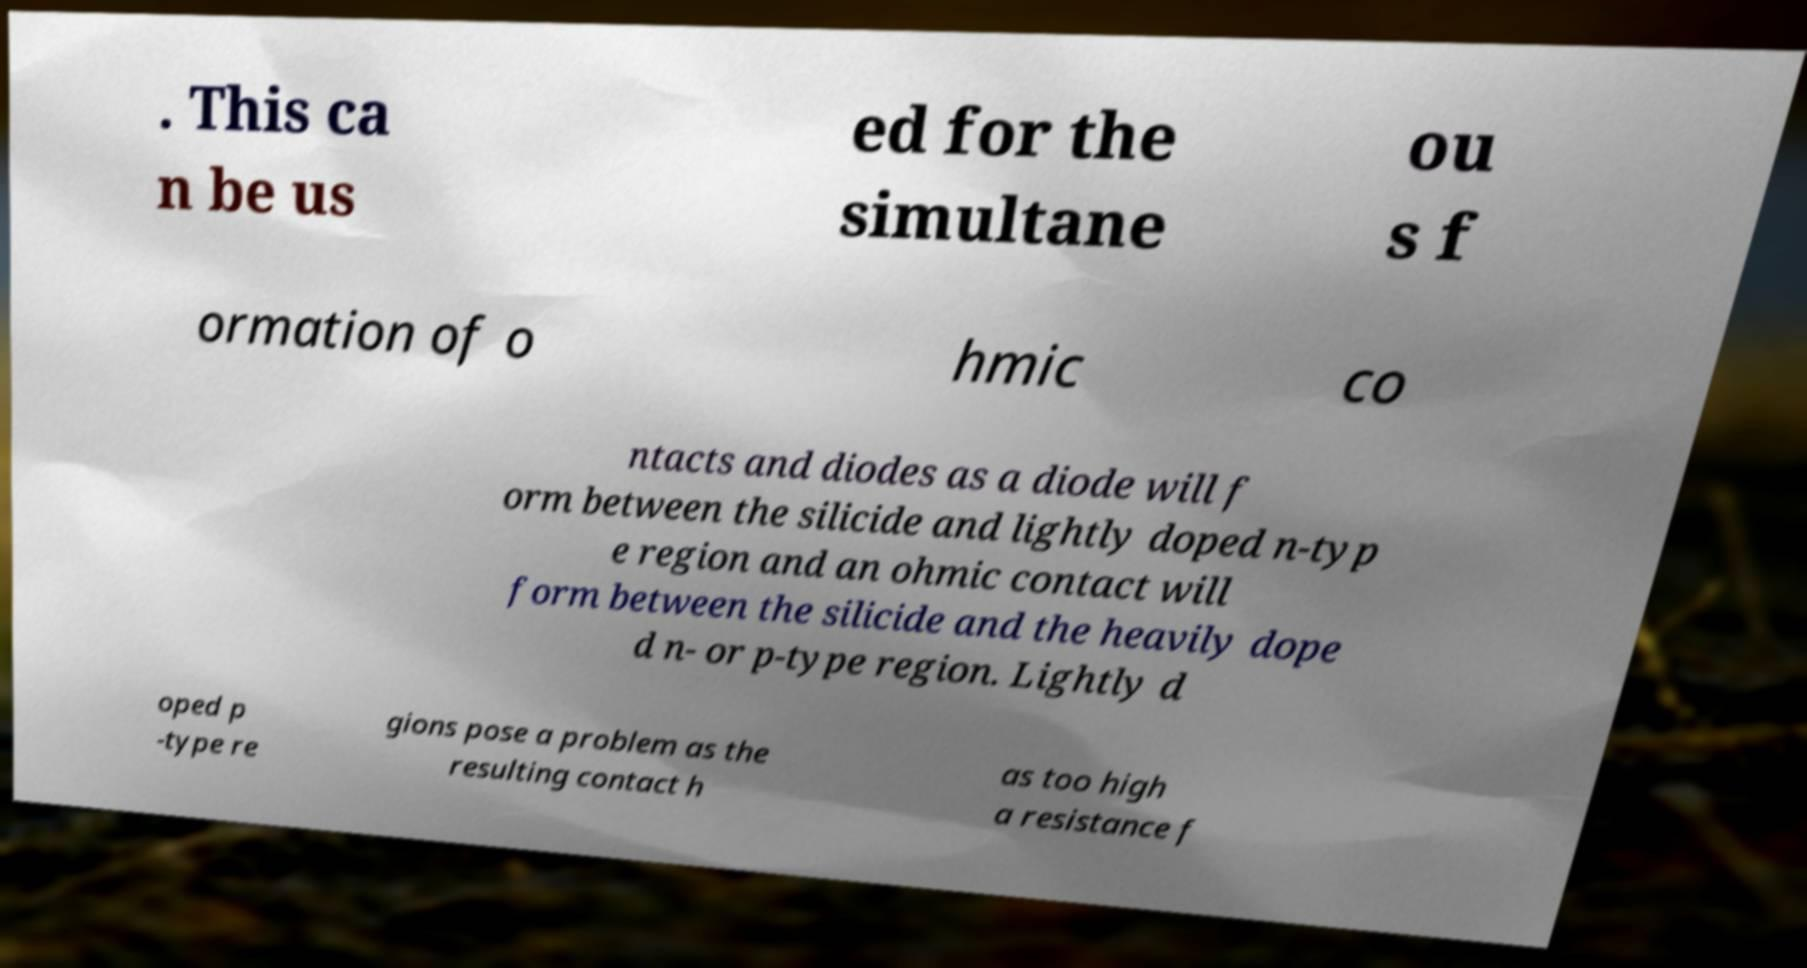I need the written content from this picture converted into text. Can you do that? . This ca n be us ed for the simultane ou s f ormation of o hmic co ntacts and diodes as a diode will f orm between the silicide and lightly doped n-typ e region and an ohmic contact will form between the silicide and the heavily dope d n- or p-type region. Lightly d oped p -type re gions pose a problem as the resulting contact h as too high a resistance f 